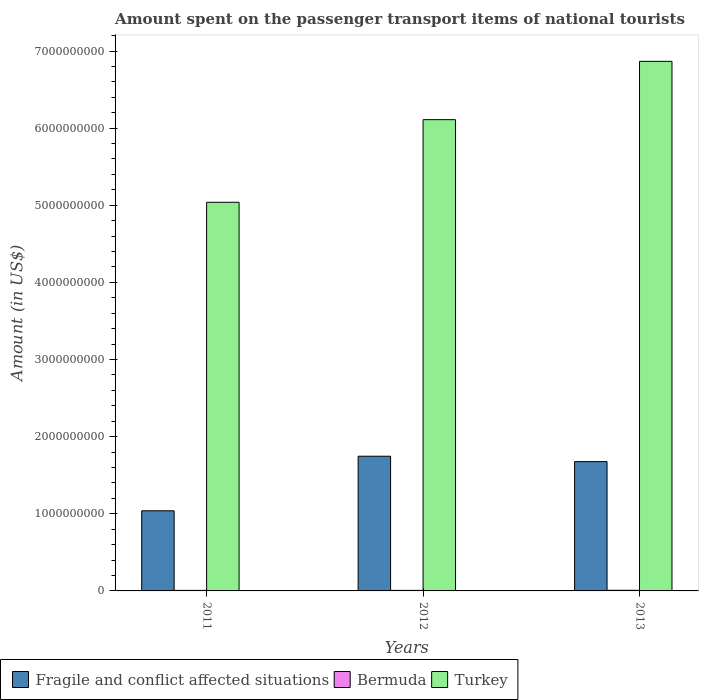How many different coloured bars are there?
Provide a succinct answer. 3. How many groups of bars are there?
Provide a succinct answer. 3. Are the number of bars per tick equal to the number of legend labels?
Keep it short and to the point. Yes. How many bars are there on the 2nd tick from the left?
Provide a short and direct response. 3. How many bars are there on the 2nd tick from the right?
Make the answer very short. 3. In how many cases, is the number of bars for a given year not equal to the number of legend labels?
Give a very brief answer. 0. What is the amount spent on the passenger transport items of national tourists in Fragile and conflict affected situations in 2013?
Your answer should be very brief. 1.68e+09. Across all years, what is the maximum amount spent on the passenger transport items of national tourists in Turkey?
Make the answer very short. 6.87e+09. Across all years, what is the minimum amount spent on the passenger transport items of national tourists in Fragile and conflict affected situations?
Make the answer very short. 1.04e+09. In which year was the amount spent on the passenger transport items of national tourists in Turkey maximum?
Ensure brevity in your answer.  2013. In which year was the amount spent on the passenger transport items of national tourists in Fragile and conflict affected situations minimum?
Give a very brief answer. 2011. What is the total amount spent on the passenger transport items of national tourists in Turkey in the graph?
Your answer should be compact. 1.80e+1. What is the difference between the amount spent on the passenger transport items of national tourists in Turkey in 2012 and that in 2013?
Provide a short and direct response. -7.56e+08. What is the difference between the amount spent on the passenger transport items of national tourists in Fragile and conflict affected situations in 2011 and the amount spent on the passenger transport items of national tourists in Bermuda in 2012?
Provide a short and direct response. 1.03e+09. What is the average amount spent on the passenger transport items of national tourists in Bermuda per year?
Ensure brevity in your answer.  7.33e+06. In the year 2012, what is the difference between the amount spent on the passenger transport items of national tourists in Fragile and conflict affected situations and amount spent on the passenger transport items of national tourists in Bermuda?
Your answer should be very brief. 1.74e+09. In how many years, is the amount spent on the passenger transport items of national tourists in Fragile and conflict affected situations greater than 5600000000 US$?
Your answer should be very brief. 0. What is the ratio of the amount spent on the passenger transport items of national tourists in Turkey in 2011 to that in 2013?
Make the answer very short. 0.73. Is the amount spent on the passenger transport items of national tourists in Fragile and conflict affected situations in 2012 less than that in 2013?
Your answer should be compact. No. What is the difference between the highest and the second highest amount spent on the passenger transport items of national tourists in Fragile and conflict affected situations?
Provide a succinct answer. 7.01e+07. What is the difference between the highest and the lowest amount spent on the passenger transport items of national tourists in Turkey?
Your response must be concise. 1.83e+09. In how many years, is the amount spent on the passenger transport items of national tourists in Fragile and conflict affected situations greater than the average amount spent on the passenger transport items of national tourists in Fragile and conflict affected situations taken over all years?
Offer a terse response. 2. What does the 3rd bar from the left in 2011 represents?
Offer a very short reply. Turkey. What does the 3rd bar from the right in 2011 represents?
Provide a short and direct response. Fragile and conflict affected situations. Is it the case that in every year, the sum of the amount spent on the passenger transport items of national tourists in Turkey and amount spent on the passenger transport items of national tourists in Bermuda is greater than the amount spent on the passenger transport items of national tourists in Fragile and conflict affected situations?
Ensure brevity in your answer.  Yes. Are the values on the major ticks of Y-axis written in scientific E-notation?
Offer a terse response. No. Does the graph contain any zero values?
Keep it short and to the point. No. Does the graph contain grids?
Your response must be concise. No. What is the title of the graph?
Your answer should be very brief. Amount spent on the passenger transport items of national tourists. What is the label or title of the Y-axis?
Offer a very short reply. Amount (in US$). What is the Amount (in US$) of Fragile and conflict affected situations in 2011?
Provide a succinct answer. 1.04e+09. What is the Amount (in US$) in Turkey in 2011?
Give a very brief answer. 5.04e+09. What is the Amount (in US$) in Fragile and conflict affected situations in 2012?
Ensure brevity in your answer.  1.75e+09. What is the Amount (in US$) in Bermuda in 2012?
Offer a very short reply. 7.00e+06. What is the Amount (in US$) of Turkey in 2012?
Provide a short and direct response. 6.11e+09. What is the Amount (in US$) of Fragile and conflict affected situations in 2013?
Offer a terse response. 1.68e+09. What is the Amount (in US$) in Bermuda in 2013?
Your answer should be compact. 8.00e+06. What is the Amount (in US$) in Turkey in 2013?
Provide a short and direct response. 6.87e+09. Across all years, what is the maximum Amount (in US$) in Fragile and conflict affected situations?
Your answer should be compact. 1.75e+09. Across all years, what is the maximum Amount (in US$) in Bermuda?
Offer a terse response. 8.00e+06. Across all years, what is the maximum Amount (in US$) of Turkey?
Your answer should be very brief. 6.87e+09. Across all years, what is the minimum Amount (in US$) of Fragile and conflict affected situations?
Give a very brief answer. 1.04e+09. Across all years, what is the minimum Amount (in US$) of Turkey?
Offer a terse response. 5.04e+09. What is the total Amount (in US$) of Fragile and conflict affected situations in the graph?
Keep it short and to the point. 4.46e+09. What is the total Amount (in US$) of Bermuda in the graph?
Give a very brief answer. 2.20e+07. What is the total Amount (in US$) of Turkey in the graph?
Your answer should be compact. 1.80e+1. What is the difference between the Amount (in US$) in Fragile and conflict affected situations in 2011 and that in 2012?
Your response must be concise. -7.07e+08. What is the difference between the Amount (in US$) in Bermuda in 2011 and that in 2012?
Provide a short and direct response. 0. What is the difference between the Amount (in US$) of Turkey in 2011 and that in 2012?
Provide a succinct answer. -1.07e+09. What is the difference between the Amount (in US$) in Fragile and conflict affected situations in 2011 and that in 2013?
Offer a terse response. -6.37e+08. What is the difference between the Amount (in US$) in Bermuda in 2011 and that in 2013?
Your answer should be very brief. -1.00e+06. What is the difference between the Amount (in US$) of Turkey in 2011 and that in 2013?
Your response must be concise. -1.83e+09. What is the difference between the Amount (in US$) of Fragile and conflict affected situations in 2012 and that in 2013?
Provide a short and direct response. 7.01e+07. What is the difference between the Amount (in US$) of Turkey in 2012 and that in 2013?
Provide a short and direct response. -7.56e+08. What is the difference between the Amount (in US$) of Fragile and conflict affected situations in 2011 and the Amount (in US$) of Bermuda in 2012?
Give a very brief answer. 1.03e+09. What is the difference between the Amount (in US$) of Fragile and conflict affected situations in 2011 and the Amount (in US$) of Turkey in 2012?
Offer a terse response. -5.07e+09. What is the difference between the Amount (in US$) of Bermuda in 2011 and the Amount (in US$) of Turkey in 2012?
Provide a succinct answer. -6.10e+09. What is the difference between the Amount (in US$) of Fragile and conflict affected situations in 2011 and the Amount (in US$) of Bermuda in 2013?
Ensure brevity in your answer.  1.03e+09. What is the difference between the Amount (in US$) of Fragile and conflict affected situations in 2011 and the Amount (in US$) of Turkey in 2013?
Your response must be concise. -5.83e+09. What is the difference between the Amount (in US$) of Bermuda in 2011 and the Amount (in US$) of Turkey in 2013?
Keep it short and to the point. -6.86e+09. What is the difference between the Amount (in US$) in Fragile and conflict affected situations in 2012 and the Amount (in US$) in Bermuda in 2013?
Offer a terse response. 1.74e+09. What is the difference between the Amount (in US$) of Fragile and conflict affected situations in 2012 and the Amount (in US$) of Turkey in 2013?
Provide a succinct answer. -5.12e+09. What is the difference between the Amount (in US$) in Bermuda in 2012 and the Amount (in US$) in Turkey in 2013?
Provide a succinct answer. -6.86e+09. What is the average Amount (in US$) in Fragile and conflict affected situations per year?
Your answer should be compact. 1.49e+09. What is the average Amount (in US$) in Bermuda per year?
Give a very brief answer. 7.33e+06. What is the average Amount (in US$) in Turkey per year?
Give a very brief answer. 6.00e+09. In the year 2011, what is the difference between the Amount (in US$) of Fragile and conflict affected situations and Amount (in US$) of Bermuda?
Your answer should be compact. 1.03e+09. In the year 2011, what is the difference between the Amount (in US$) in Fragile and conflict affected situations and Amount (in US$) in Turkey?
Your answer should be compact. -4.00e+09. In the year 2011, what is the difference between the Amount (in US$) of Bermuda and Amount (in US$) of Turkey?
Your response must be concise. -5.03e+09. In the year 2012, what is the difference between the Amount (in US$) of Fragile and conflict affected situations and Amount (in US$) of Bermuda?
Offer a terse response. 1.74e+09. In the year 2012, what is the difference between the Amount (in US$) of Fragile and conflict affected situations and Amount (in US$) of Turkey?
Your answer should be very brief. -4.36e+09. In the year 2012, what is the difference between the Amount (in US$) of Bermuda and Amount (in US$) of Turkey?
Provide a short and direct response. -6.10e+09. In the year 2013, what is the difference between the Amount (in US$) of Fragile and conflict affected situations and Amount (in US$) of Bermuda?
Ensure brevity in your answer.  1.67e+09. In the year 2013, what is the difference between the Amount (in US$) in Fragile and conflict affected situations and Amount (in US$) in Turkey?
Provide a short and direct response. -5.19e+09. In the year 2013, what is the difference between the Amount (in US$) of Bermuda and Amount (in US$) of Turkey?
Your answer should be compact. -6.86e+09. What is the ratio of the Amount (in US$) of Fragile and conflict affected situations in 2011 to that in 2012?
Keep it short and to the point. 0.59. What is the ratio of the Amount (in US$) of Bermuda in 2011 to that in 2012?
Ensure brevity in your answer.  1. What is the ratio of the Amount (in US$) in Turkey in 2011 to that in 2012?
Keep it short and to the point. 0.82. What is the ratio of the Amount (in US$) in Fragile and conflict affected situations in 2011 to that in 2013?
Offer a very short reply. 0.62. What is the ratio of the Amount (in US$) of Turkey in 2011 to that in 2013?
Your answer should be compact. 0.73. What is the ratio of the Amount (in US$) of Fragile and conflict affected situations in 2012 to that in 2013?
Provide a succinct answer. 1.04. What is the ratio of the Amount (in US$) in Bermuda in 2012 to that in 2013?
Give a very brief answer. 0.88. What is the ratio of the Amount (in US$) of Turkey in 2012 to that in 2013?
Make the answer very short. 0.89. What is the difference between the highest and the second highest Amount (in US$) of Fragile and conflict affected situations?
Provide a short and direct response. 7.01e+07. What is the difference between the highest and the second highest Amount (in US$) of Bermuda?
Provide a succinct answer. 1.00e+06. What is the difference between the highest and the second highest Amount (in US$) of Turkey?
Give a very brief answer. 7.56e+08. What is the difference between the highest and the lowest Amount (in US$) in Fragile and conflict affected situations?
Offer a very short reply. 7.07e+08. What is the difference between the highest and the lowest Amount (in US$) in Turkey?
Provide a short and direct response. 1.83e+09. 